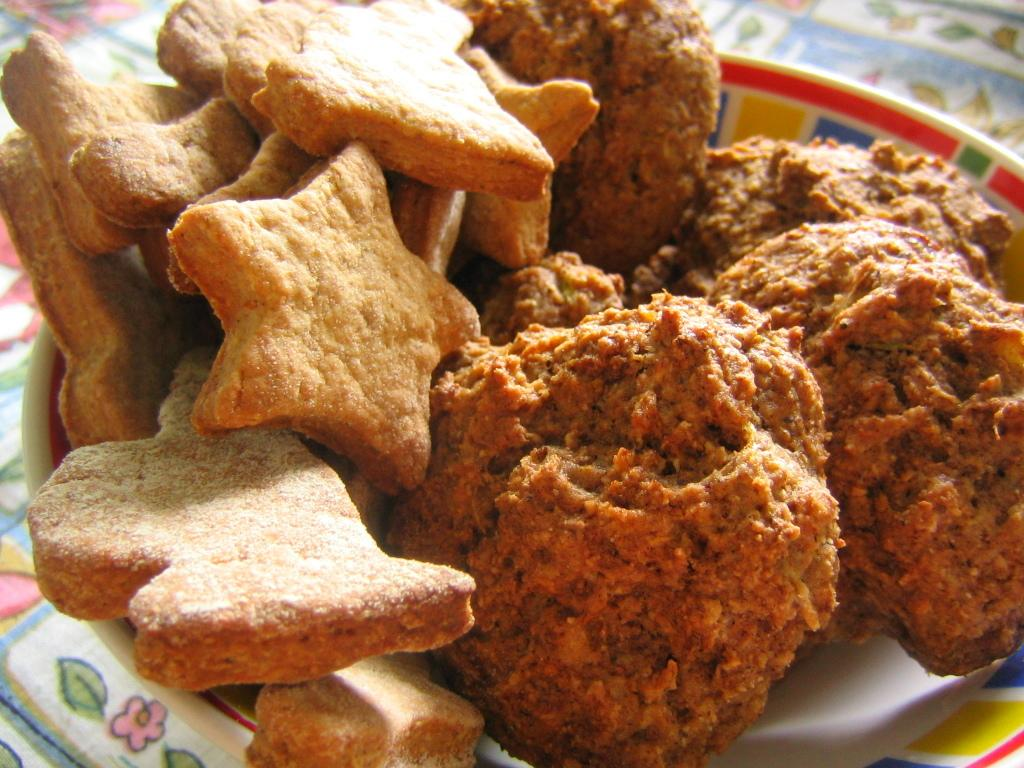What type of items can be seen in the image? There are food items in the image. How are the food items arranged in the image? The food items are placed in a bowl. Where is the bowl located in the image? The bowl is on a table. What is the condition of the discussion happening in the image? There is no discussion present in the image; it only features food items in a bowl on a table. 